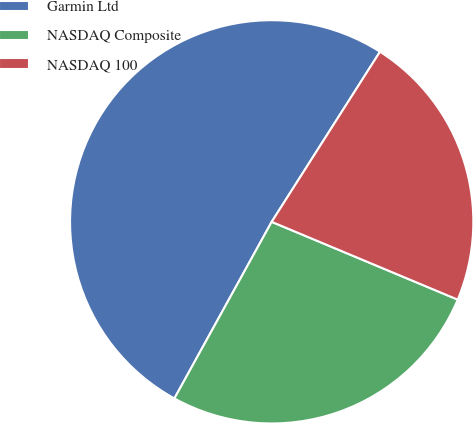Convert chart. <chart><loc_0><loc_0><loc_500><loc_500><pie_chart><fcel>Garmin Ltd<fcel>NASDAQ Composite<fcel>NASDAQ 100<nl><fcel>51.01%<fcel>26.71%<fcel>22.28%<nl></chart> 